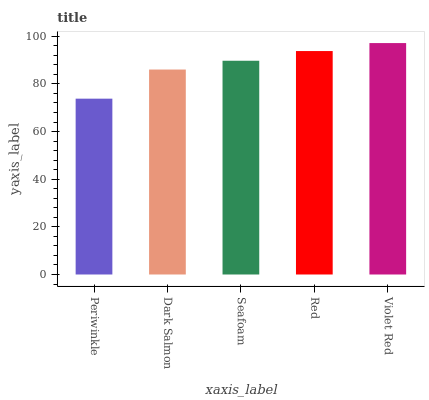Is Dark Salmon the minimum?
Answer yes or no. No. Is Dark Salmon the maximum?
Answer yes or no. No. Is Dark Salmon greater than Periwinkle?
Answer yes or no. Yes. Is Periwinkle less than Dark Salmon?
Answer yes or no. Yes. Is Periwinkle greater than Dark Salmon?
Answer yes or no. No. Is Dark Salmon less than Periwinkle?
Answer yes or no. No. Is Seafoam the high median?
Answer yes or no. Yes. Is Seafoam the low median?
Answer yes or no. Yes. Is Violet Red the high median?
Answer yes or no. No. Is Periwinkle the low median?
Answer yes or no. No. 